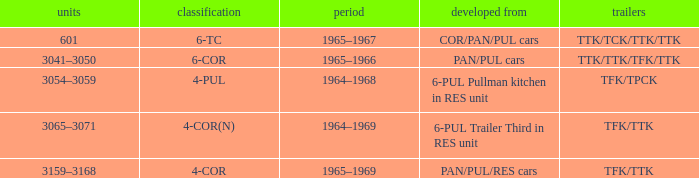Name the typed for formed from 6-pul trailer third in res unit 4-COR(N). 